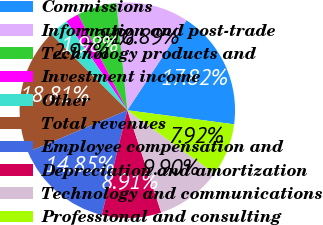<chart> <loc_0><loc_0><loc_500><loc_500><pie_chart><fcel>Commissions<fcel>Information and post-trade<fcel>Technology products and<fcel>Investment income<fcel>Other<fcel>Total revenues<fcel>Employee compensation and<fcel>Depreciation and amortization<fcel>Technology and communications<fcel>Professional and consulting<nl><fcel>17.82%<fcel>10.89%<fcel>5.94%<fcel>1.98%<fcel>2.97%<fcel>18.81%<fcel>14.85%<fcel>8.91%<fcel>9.9%<fcel>7.92%<nl></chart> 